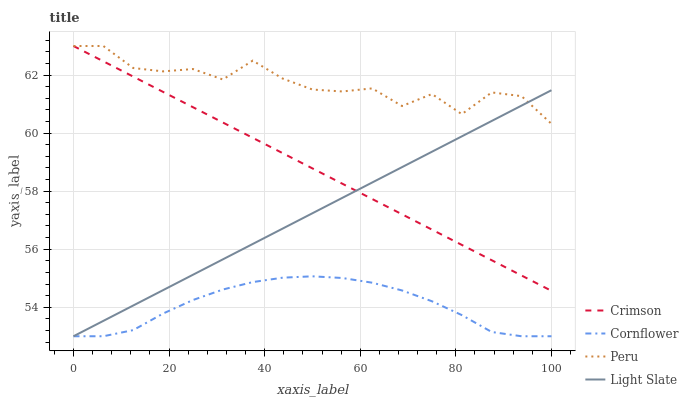Does Cornflower have the minimum area under the curve?
Answer yes or no. Yes. Does Peru have the maximum area under the curve?
Answer yes or no. Yes. Does Light Slate have the minimum area under the curve?
Answer yes or no. No. Does Light Slate have the maximum area under the curve?
Answer yes or no. No. Is Crimson the smoothest?
Answer yes or no. Yes. Is Peru the roughest?
Answer yes or no. Yes. Is Cornflower the smoothest?
Answer yes or no. No. Is Cornflower the roughest?
Answer yes or no. No. Does Cornflower have the lowest value?
Answer yes or no. Yes. Does Peru have the lowest value?
Answer yes or no. No. Does Peru have the highest value?
Answer yes or no. Yes. Does Light Slate have the highest value?
Answer yes or no. No. Is Cornflower less than Peru?
Answer yes or no. Yes. Is Peru greater than Cornflower?
Answer yes or no. Yes. Does Light Slate intersect Cornflower?
Answer yes or no. Yes. Is Light Slate less than Cornflower?
Answer yes or no. No. Is Light Slate greater than Cornflower?
Answer yes or no. No. Does Cornflower intersect Peru?
Answer yes or no. No. 